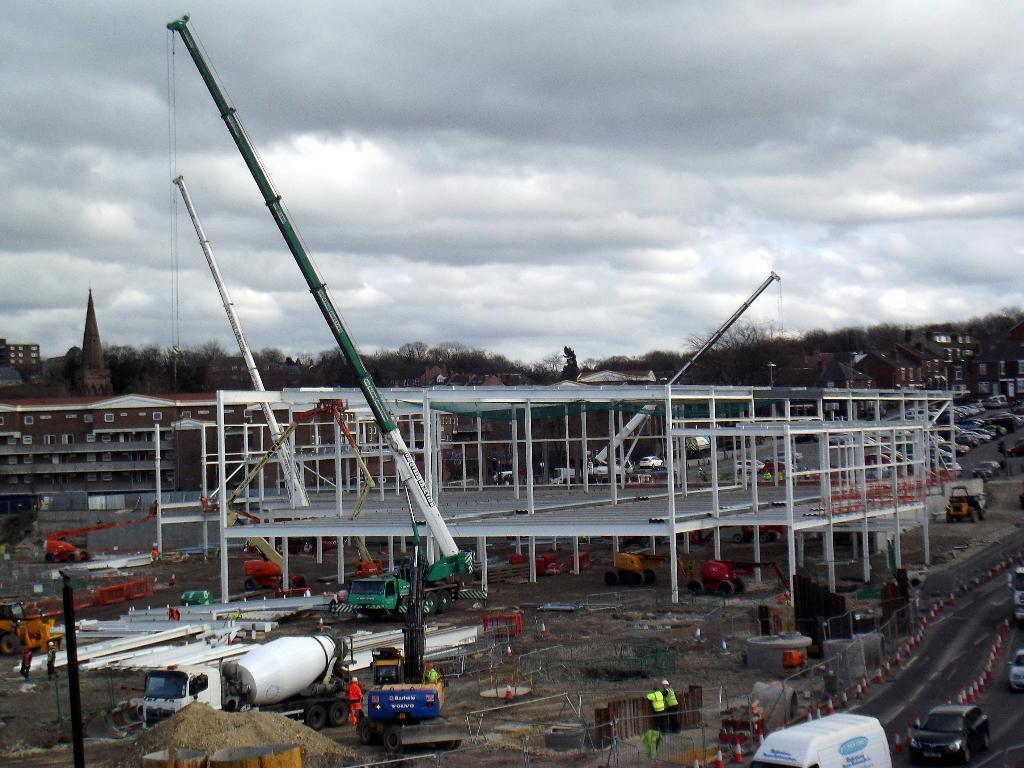In one or two sentences, can you explain what this image depicts? In the picture I can see buildings, trees, vehicles, people, poles and some other objects. In the background I can see the sky. 